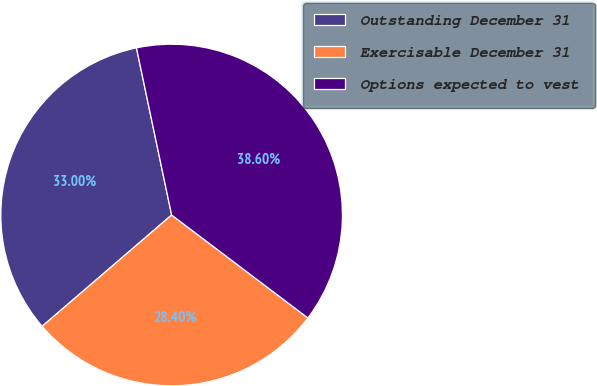Convert chart to OTSL. <chart><loc_0><loc_0><loc_500><loc_500><pie_chart><fcel>Outstanding December 31<fcel>Exercisable December 31<fcel>Options expected to vest<nl><fcel>33.0%<fcel>28.4%<fcel>38.6%<nl></chart> 